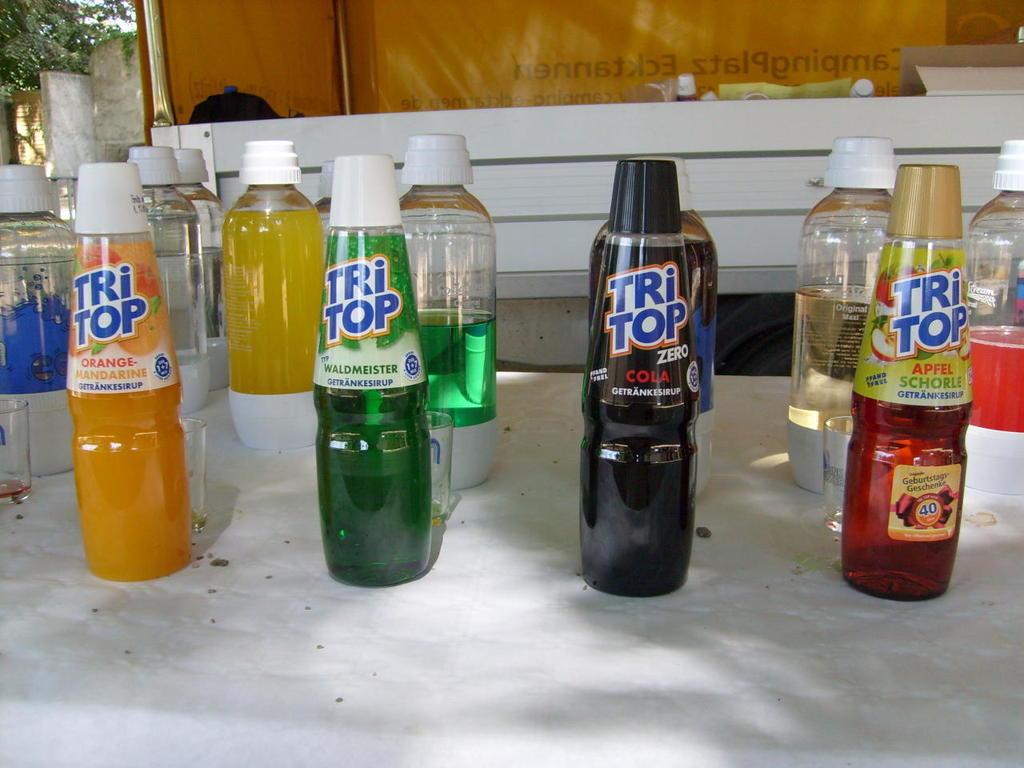Which one is orange flavored?
Your answer should be very brief. One to the left. What flavor is the green boyyle?
Make the answer very short. Waldmeister. 